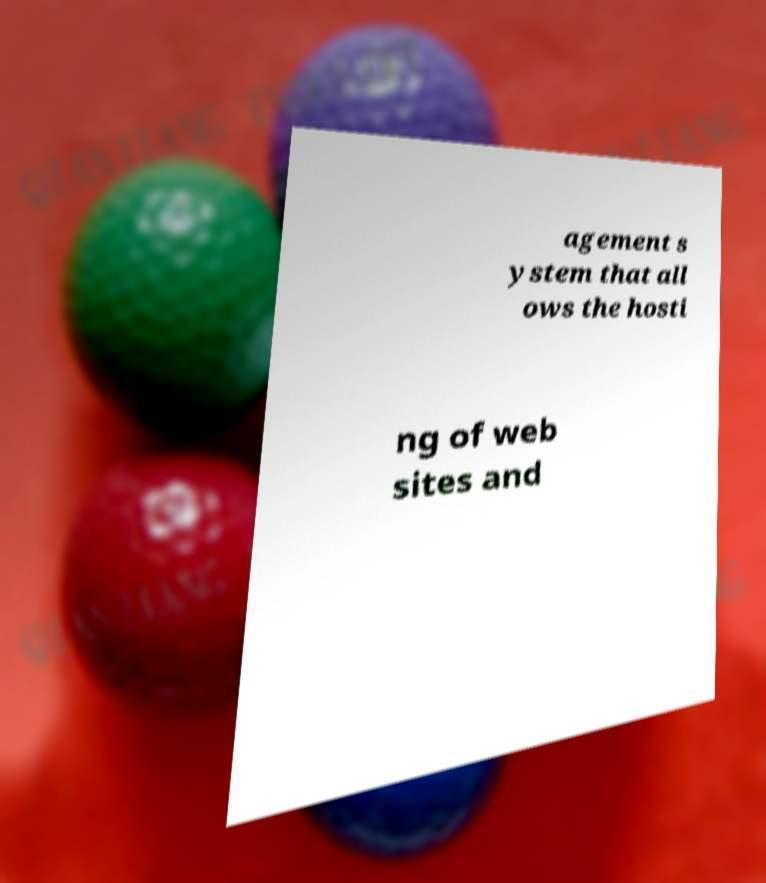There's text embedded in this image that I need extracted. Can you transcribe it verbatim? agement s ystem that all ows the hosti ng of web sites and 